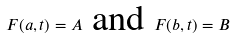<formula> <loc_0><loc_0><loc_500><loc_500>F ( a , t ) = A \text { and } F ( b , t ) = B</formula> 